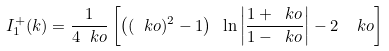<formula> <loc_0><loc_0><loc_500><loc_500>I _ { 1 } ^ { + } ( k ) = \frac { 1 } { 4 \ k o } \left [ \left ( ( \ k o ) ^ { 2 } - 1 \right ) \ \ln \left | \frac { 1 + \ k o } { 1 - \ k o } \right | - 2 \ \ k o \right ]</formula> 